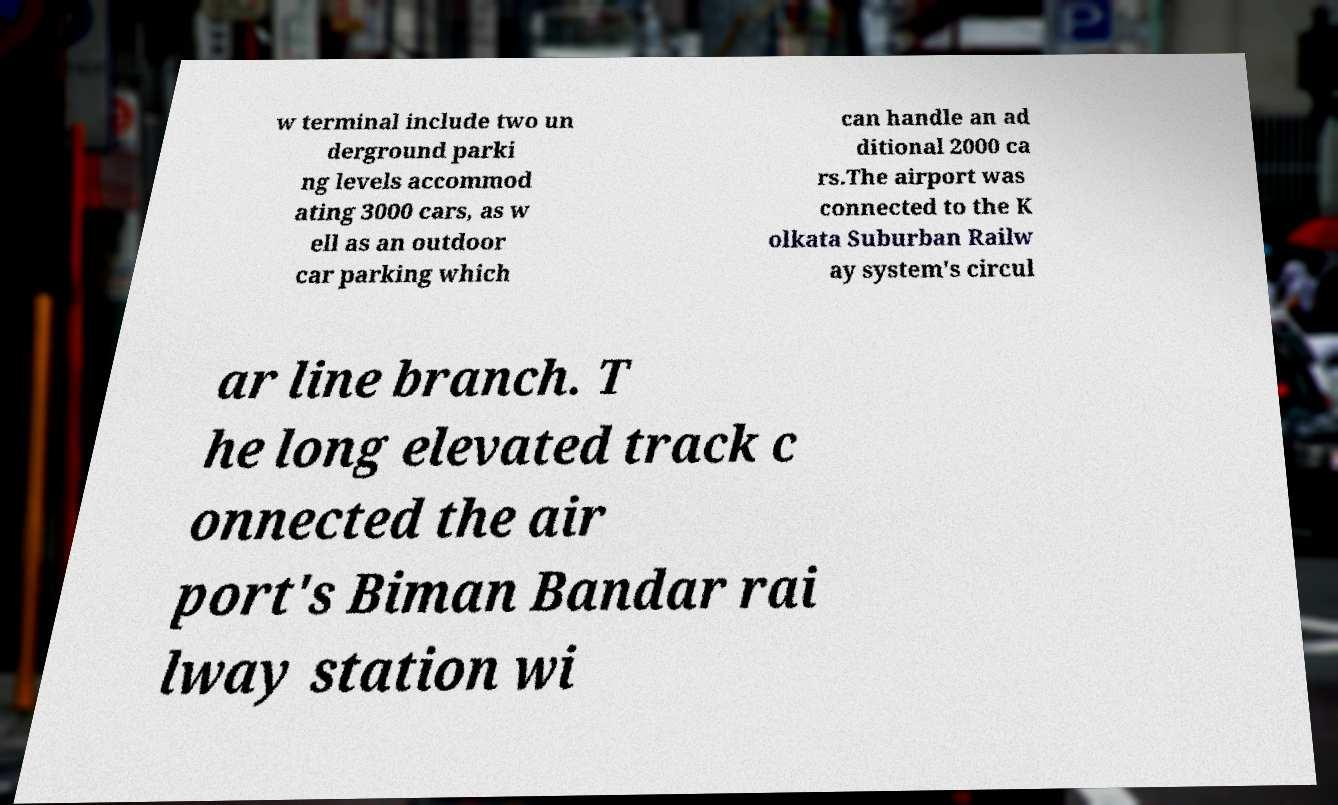Please identify and transcribe the text found in this image. w terminal include two un derground parki ng levels accommod ating 3000 cars, as w ell as an outdoor car parking which can handle an ad ditional 2000 ca rs.The airport was connected to the K olkata Suburban Railw ay system's circul ar line branch. T he long elevated track c onnected the air port's Biman Bandar rai lway station wi 